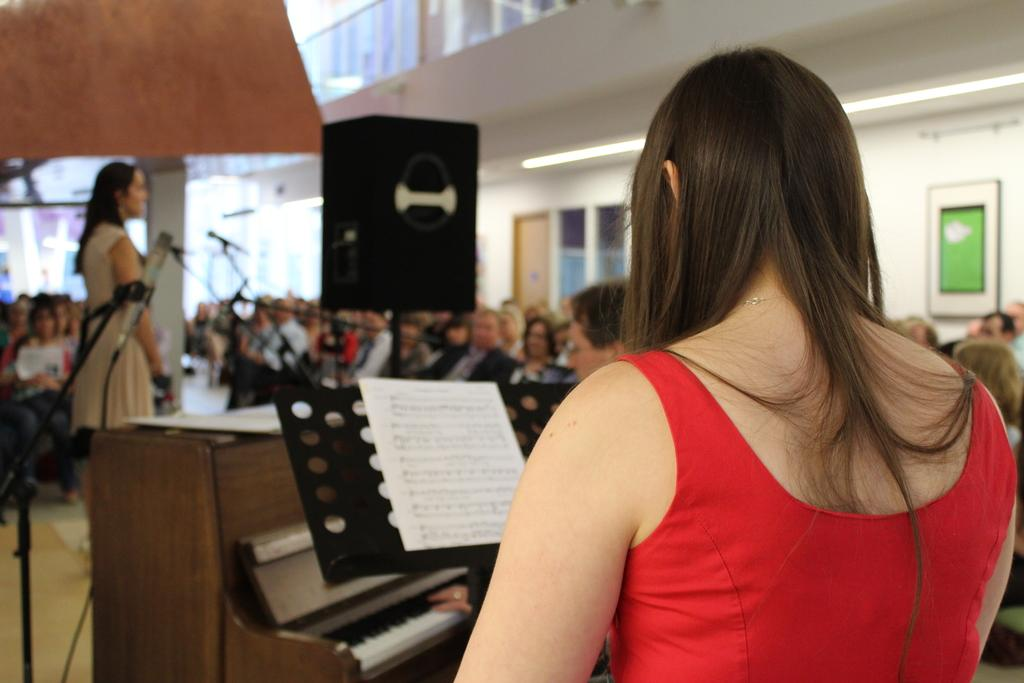How many people are present in the room? There are many people in the room. What are some of the people in the room doing? Some people are sitting, and two persons are standing. Is anyone playing an instrument in the room? Yes, one person is playing the piano. What type of minister is standing next to the downtown sign in the image? There is no minister or downtown sign present in the image. 